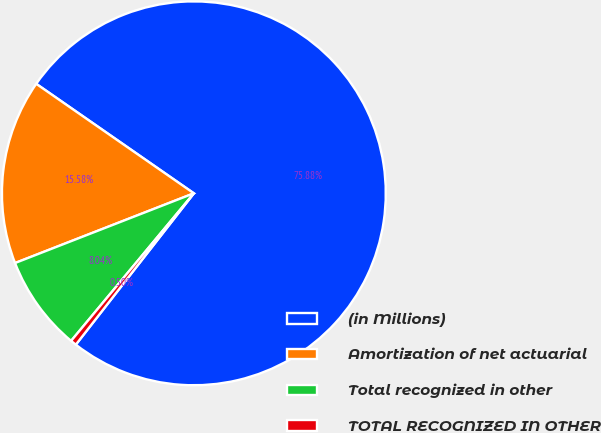<chart> <loc_0><loc_0><loc_500><loc_500><pie_chart><fcel>(in Millions)<fcel>Amortization of net actuarial<fcel>Total recognized in other<fcel>TOTAL RECOGNIZED IN OTHER<nl><fcel>75.88%<fcel>15.58%<fcel>8.04%<fcel>0.5%<nl></chart> 